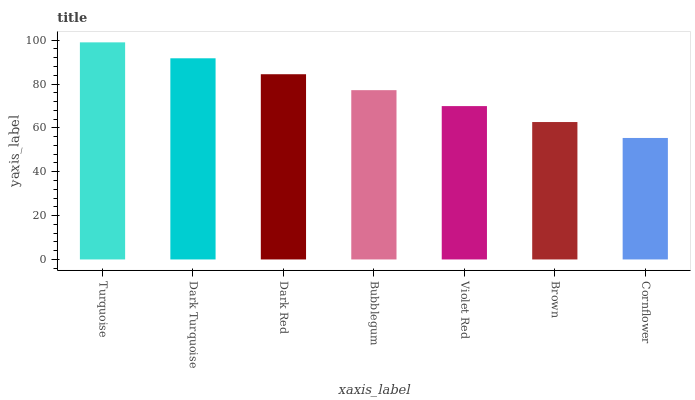Is Cornflower the minimum?
Answer yes or no. Yes. Is Turquoise the maximum?
Answer yes or no. Yes. Is Dark Turquoise the minimum?
Answer yes or no. No. Is Dark Turquoise the maximum?
Answer yes or no. No. Is Turquoise greater than Dark Turquoise?
Answer yes or no. Yes. Is Dark Turquoise less than Turquoise?
Answer yes or no. Yes. Is Dark Turquoise greater than Turquoise?
Answer yes or no. No. Is Turquoise less than Dark Turquoise?
Answer yes or no. No. Is Bubblegum the high median?
Answer yes or no. Yes. Is Bubblegum the low median?
Answer yes or no. Yes. Is Dark Turquoise the high median?
Answer yes or no. No. Is Cornflower the low median?
Answer yes or no. No. 